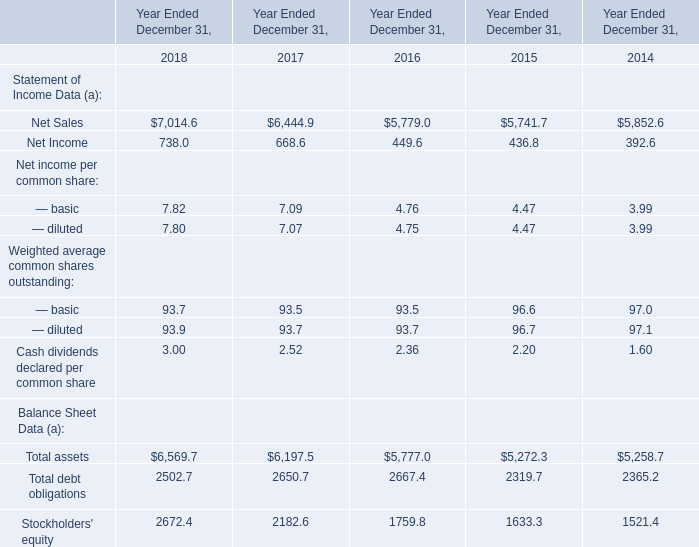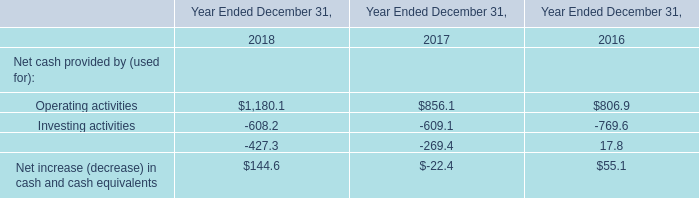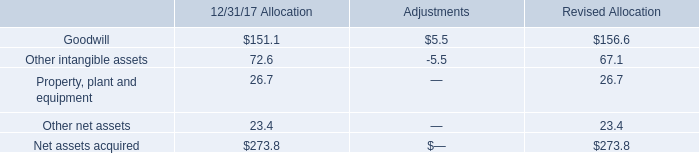Which year has the greatest proportion of — basic? 
Answer: 2018. 